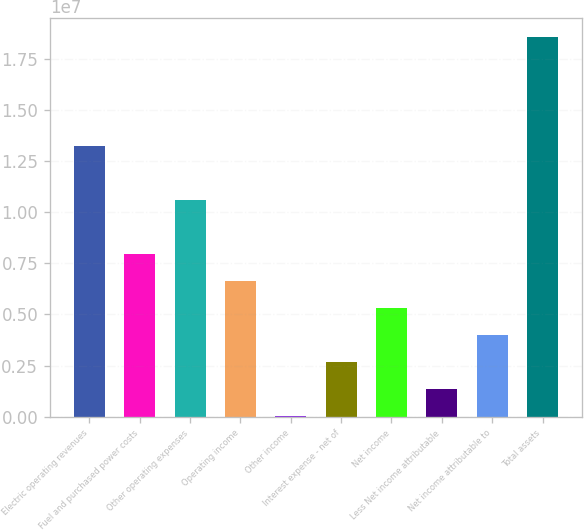Convert chart. <chart><loc_0><loc_0><loc_500><loc_500><bar_chart><fcel>Electric operating revenues<fcel>Fuel and purchased power costs<fcel>Other operating expenses<fcel>Operating income<fcel>Other income<fcel>Interest expense - net of<fcel>Net income<fcel>Less Net income attributable<fcel>Net income attributable to<fcel>Total assets<nl><fcel>1.32425e+07<fcel>7.95207e+06<fcel>1.05973e+07<fcel>6.62945e+06<fcel>16358<fcel>2.66159e+06<fcel>5.30683e+06<fcel>1.33898e+06<fcel>3.98421e+06<fcel>1.8533e+07<nl></chart> 